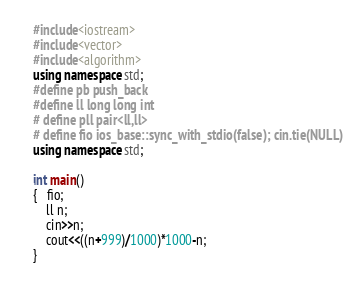<code> <loc_0><loc_0><loc_500><loc_500><_C++_>#include<iostream>
#include<vector>
#include<algorithm>
using namespace std;
#define pb push_back
#define ll long long int
# define pll pair<ll,ll>
# define fio ios_base::sync_with_stdio(false); cin.tie(NULL)
using namespace std;

int main()
{   fio;
    ll n;
    cin>>n;
    cout<<((n+999)/1000)*1000-n;
}
</code> 